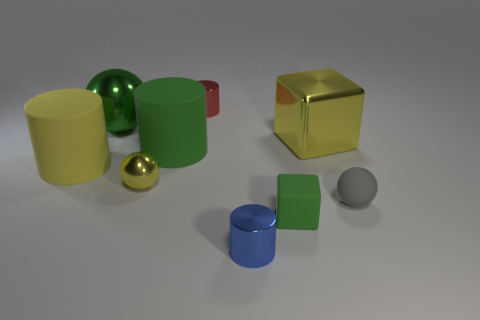What shape is the big shiny thing that is the same color as the small metallic sphere?
Offer a terse response. Cube. Does the green cylinder have the same size as the cylinder behind the big yellow cube?
Keep it short and to the point. No. What is the cylinder on the left side of the green metallic object made of?
Offer a terse response. Rubber. There is a gray thing that is to the right of the small green block; what number of tiny yellow spheres are in front of it?
Provide a short and direct response. 0. Is there a small cyan shiny thing of the same shape as the blue object?
Provide a succinct answer. No. Is the size of the rubber object that is in front of the gray matte sphere the same as the yellow metallic object left of the tiny blue metallic object?
Provide a short and direct response. Yes. What is the shape of the rubber thing that is right of the green object in front of the gray rubber object?
Your answer should be compact. Sphere. How many blue cylinders are the same size as the red shiny cylinder?
Make the answer very short. 1. Are there any big brown cylinders?
Your answer should be compact. No. Are there any other things of the same color as the big ball?
Offer a terse response. Yes. 